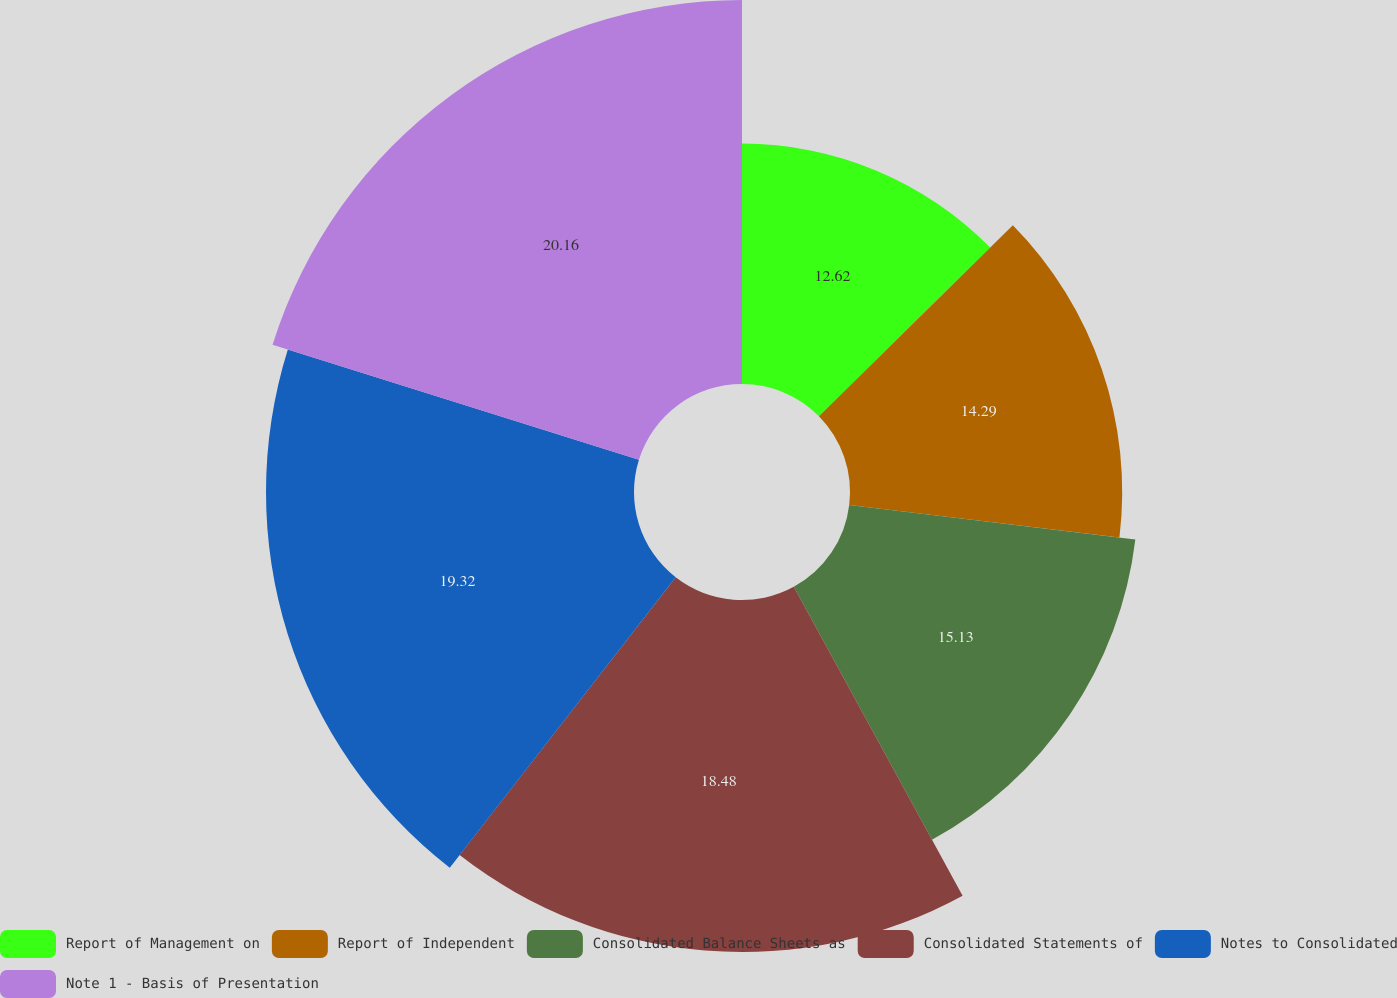<chart> <loc_0><loc_0><loc_500><loc_500><pie_chart><fcel>Report of Management on<fcel>Report of Independent<fcel>Consolidated Balance Sheets as<fcel>Consolidated Statements of<fcel>Notes to Consolidated<fcel>Note 1 - Basis of Presentation<nl><fcel>12.62%<fcel>14.29%<fcel>15.13%<fcel>18.48%<fcel>19.32%<fcel>20.16%<nl></chart> 